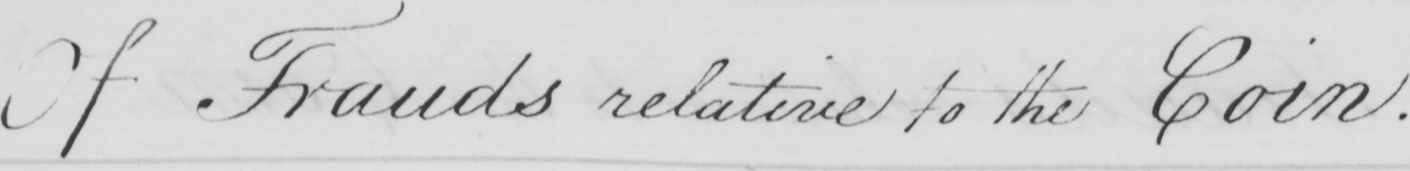What is written in this line of handwriting? Of Frauds relative to the Coin . 